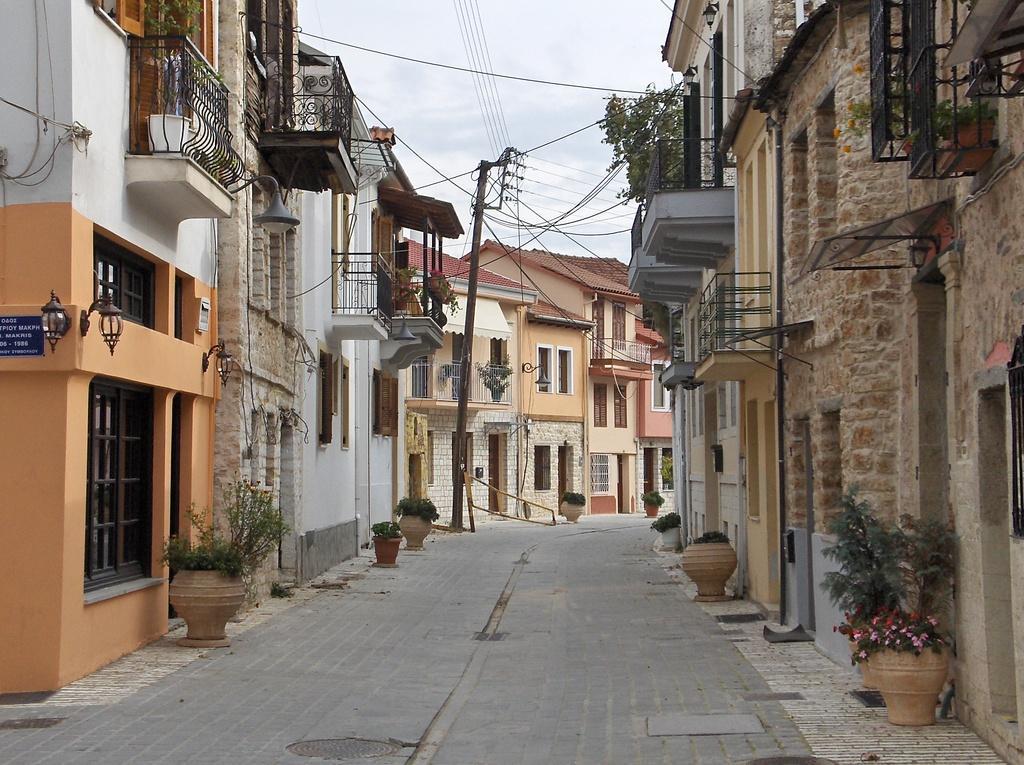How would you summarize this image in a sentence or two? In this image we can see the houses, glass windows, beside that we can see the lamps, on the left we can see text written on the board, beside that we can see fence. And we can see plants in the pots. And we can see the transmission towers and cable wires. And we can see the sky with clouds. 